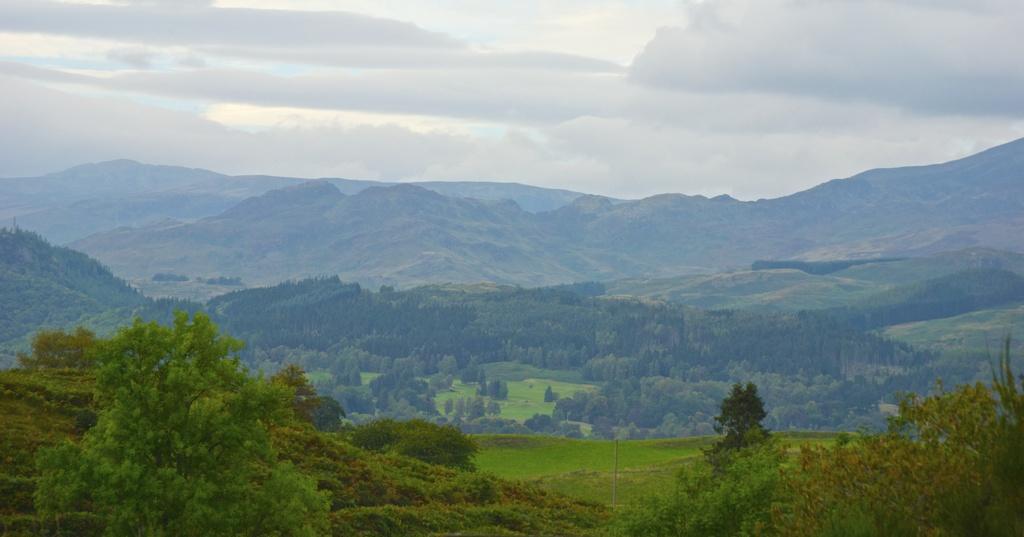Please provide a concise description of this image. As we can see in the image there are plants, grass, trees, hills, sky and clouds. 